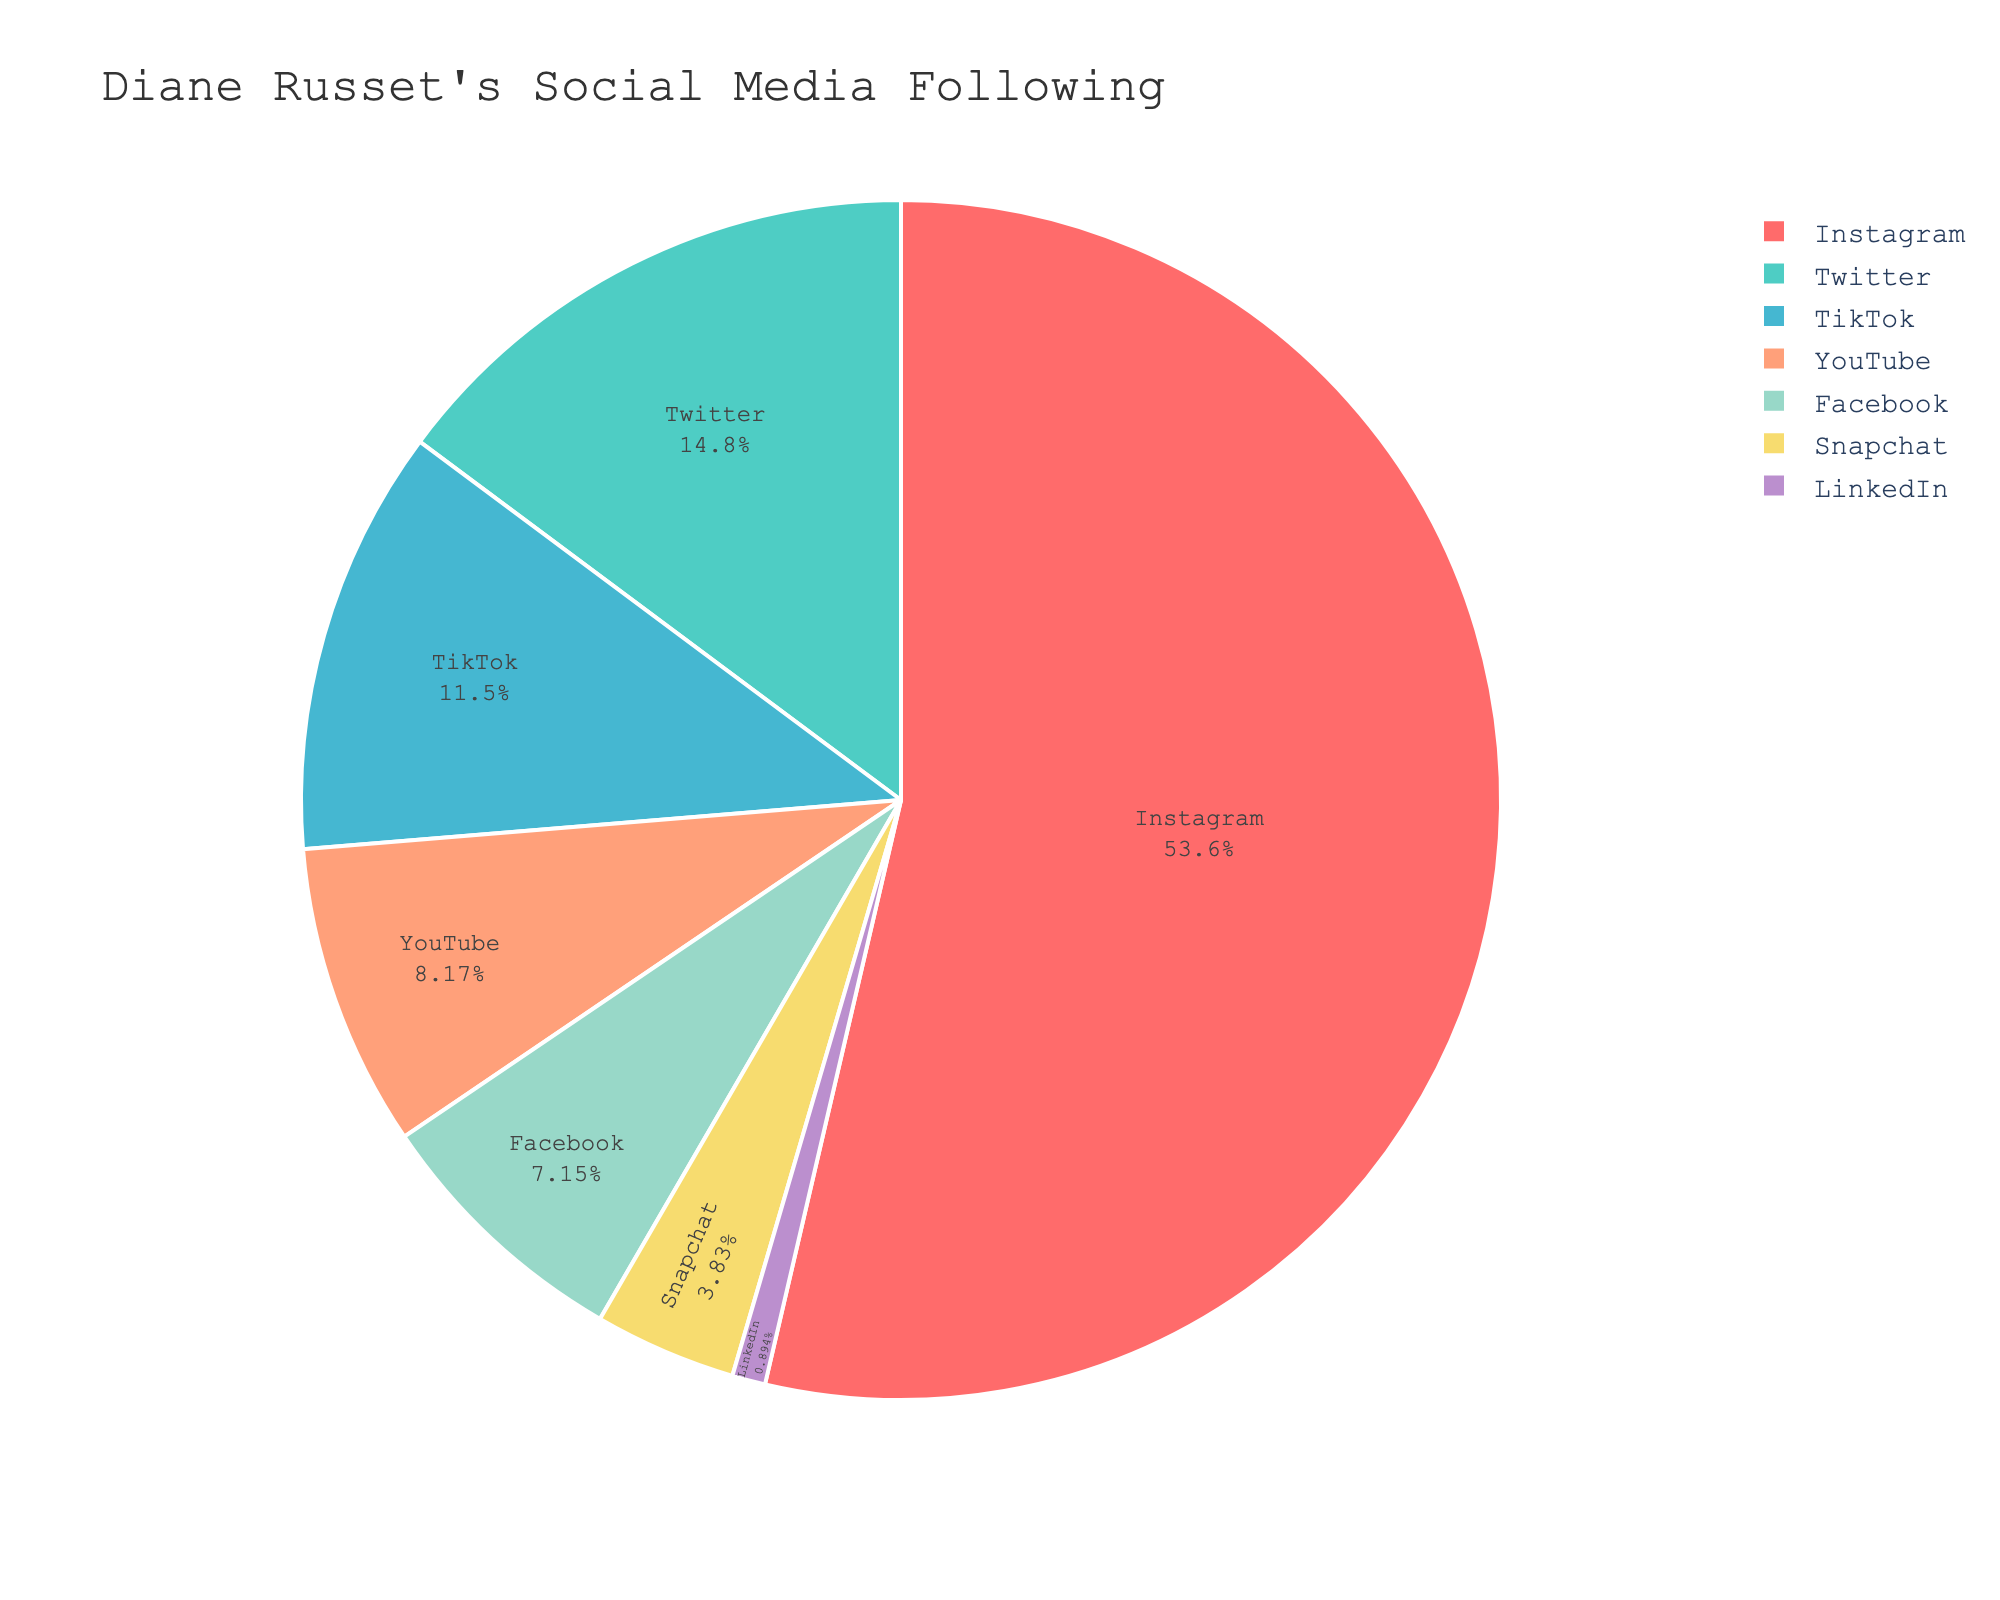Which platform has the largest number of followers? By looking at the pie chart, Instagram has the largest portion, indicating the highest number of followers.
Answer: Instagram Which platform has fewer followers, TikTok or Twitter? By examining the sizes of the segments representing TikTok and Twitter, TikTok's segment is smaller than Twitter's, showing TikTok has fewer followers.
Answer: TikTok How many more followers does Instagram have than Facebook? Instagram has 2,100,000 followers and Facebook has 280,000 followers. The difference is 2,100,000 - 280,000 = 1,820,000.
Answer: 1,820,000 Combine the followers of YouTube and Snapchat. Which platform has fewer followers than this combined number? YouTube has 320,000 followers and Snapchat has 150,000 followers. Combined, they have 470,000 followers. Platforms with fewer followers are LinkedIn (35,000) and Snapchat (150,000).
Answer: LinkedIn, Snapchat What percentage of Diane Russet's followers are on LinkedIn? The pie chart shows the followers in percentages. Look for the segment labeled LinkedIn, which represents approximately 1% of the total followers.
Answer: 1% If the top three platforms are combined, what percentage of the total followers do they represent? The top three platforms Instagram, Twitter, and TikTok have 2,100,000, 580,000, and 450,000 followers respectively. The total followers are 3,785,000. The percentage is (2,100,000 + 580,000 + 450,000) / 3,785,000 ≈ 85%.
Answer: 85% Is the difference in followers between YouTube and Facebook greater than the number of LinkedIn followers? YouTube has 320,000 followers and Facebook has 280,000 followers. The difference is 320,000 - 280,000 = 40,000. LinkedIn has 35,000 followers. Yes, 40,000 is greater than 35,000.
Answer: Yes Arrange the platforms in descending order of their followers. Order the platforms by the sizes of their segments in the pie chart: Instagram, Twitter, TikTok, YouTube, Facebook, Snapchat, LinkedIn.
Answer: Instagram, Twitter, TikTok, YouTube, Facebook, Snapchat, LinkedIn 